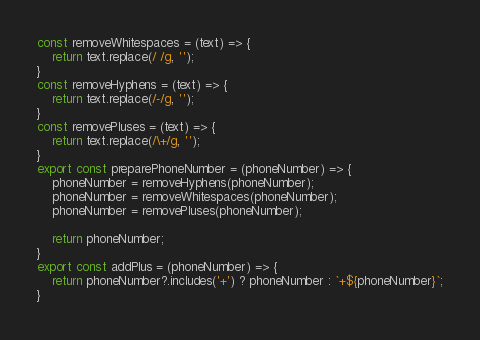Convert code to text. <code><loc_0><loc_0><loc_500><loc_500><_JavaScript_>const removeWhitespaces = (text) => {
    return text.replace(/ /g, '');
}
const removeHyphens = (text) => {
    return text.replace(/-/g, '');
}
const removePluses = (text) => {
    return text.replace(/\+/g, '');
}
export const preparePhoneNumber = (phoneNumber) => {
    phoneNumber = removeHyphens(phoneNumber);
    phoneNumber = removeWhitespaces(phoneNumber);
    phoneNumber = removePluses(phoneNumber);

    return phoneNumber;
}
export const addPlus = (phoneNumber) => {
    return phoneNumber?.includes('+') ? phoneNumber : `+${phoneNumber}`;
}</code> 